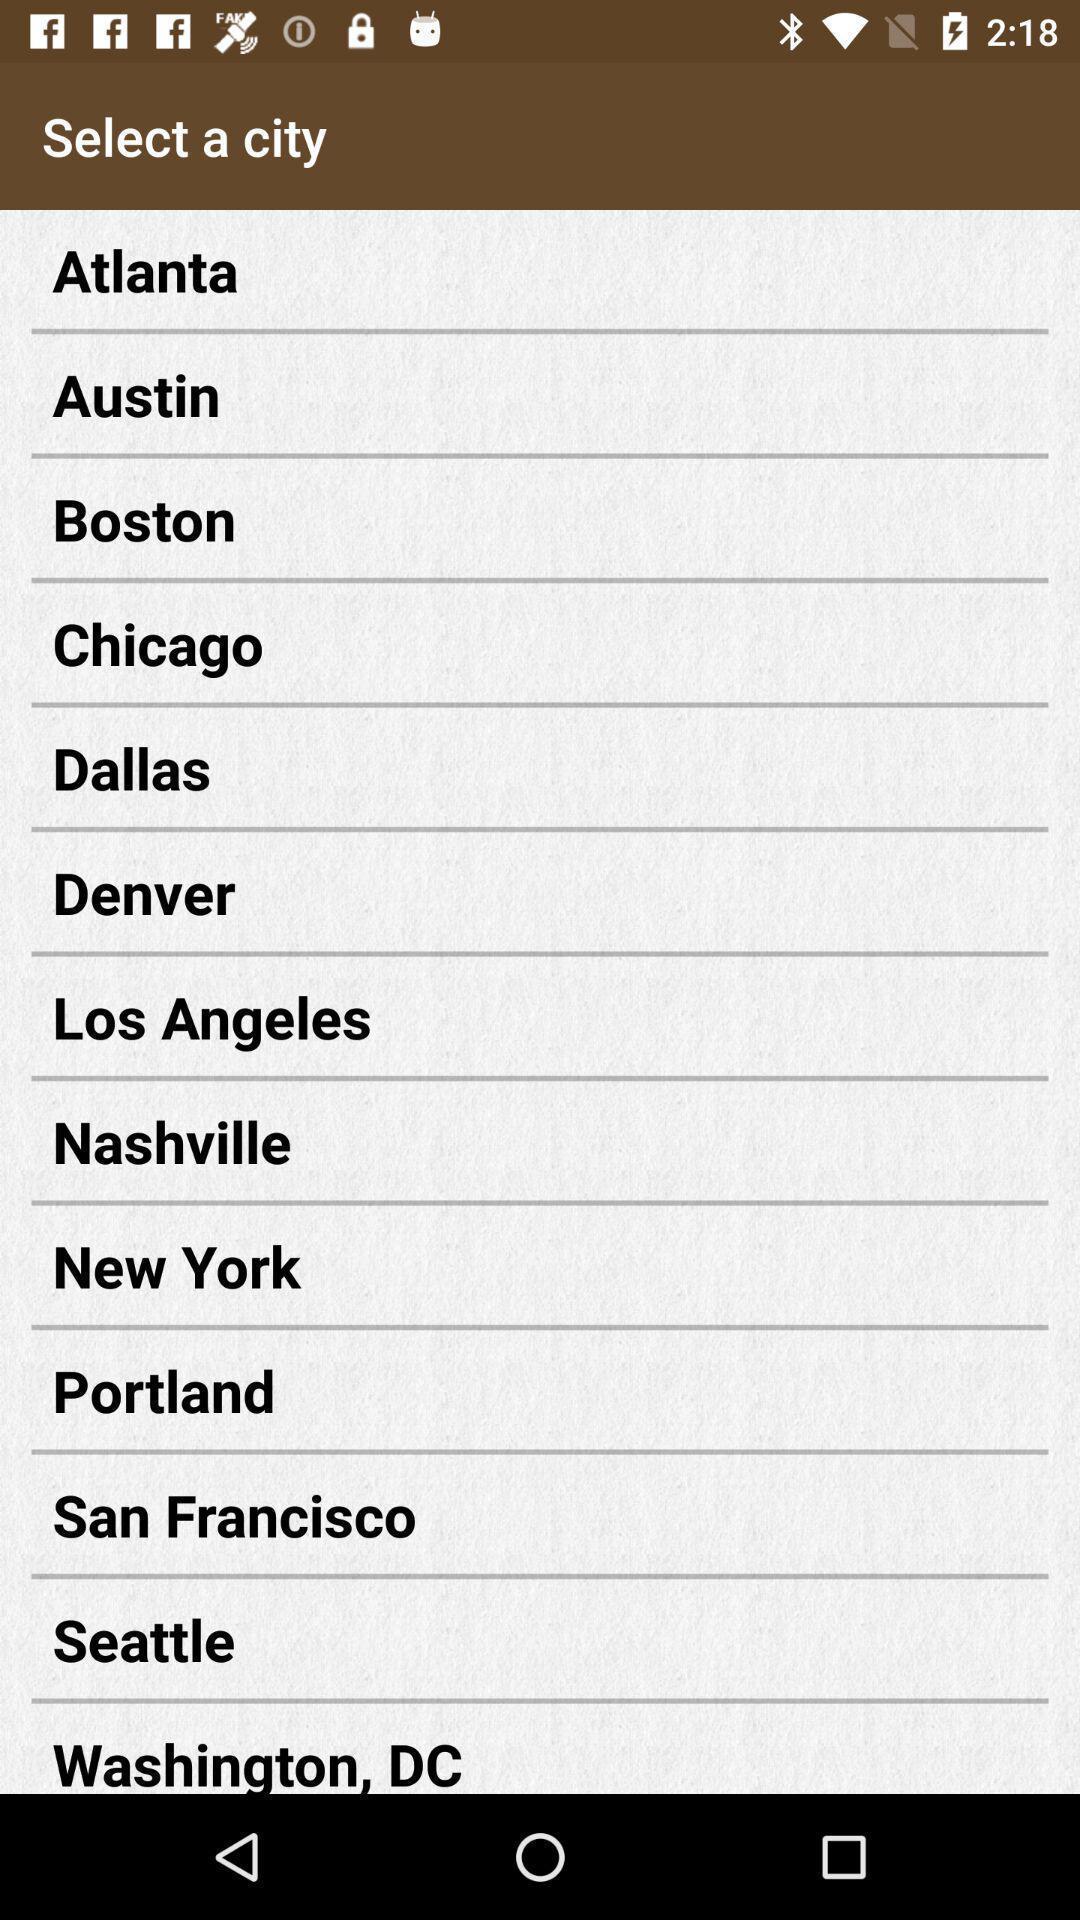What is the overall content of this screenshot? Screen page of various city names. 